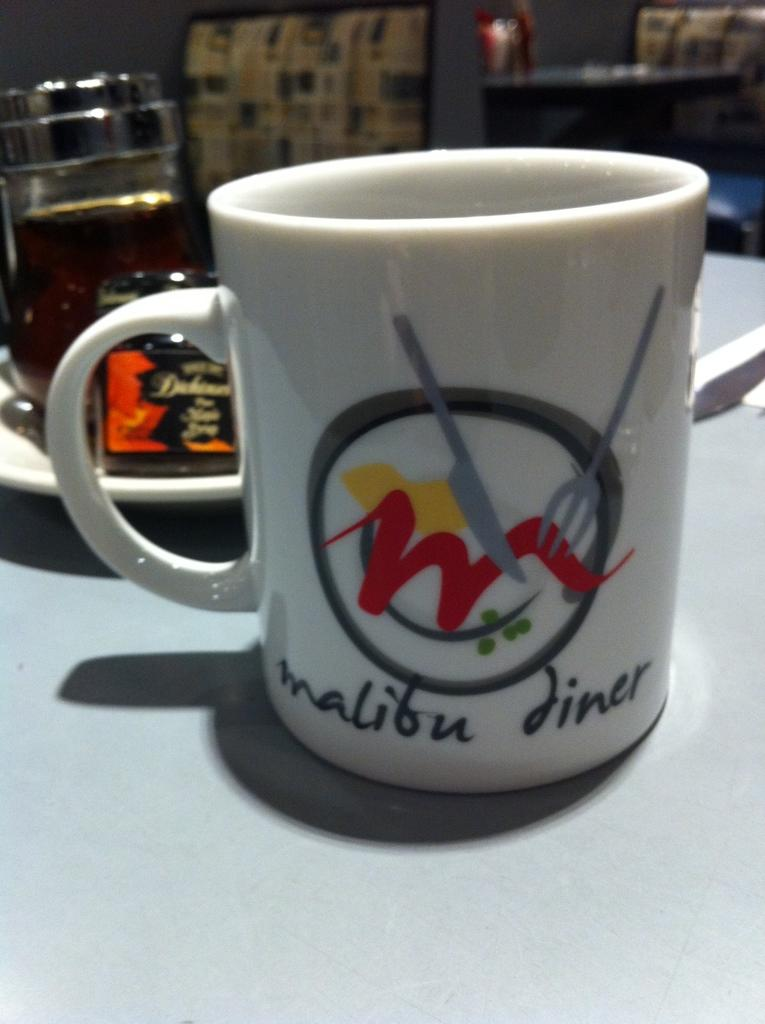<image>
Provide a brief description of the given image. A white coffee mug with a red m on the from with a fork and knife. 